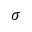Convert formula to latex. <formula><loc_0><loc_0><loc_500><loc_500>\sigma</formula> 